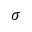Convert formula to latex. <formula><loc_0><loc_0><loc_500><loc_500>\sigma</formula> 